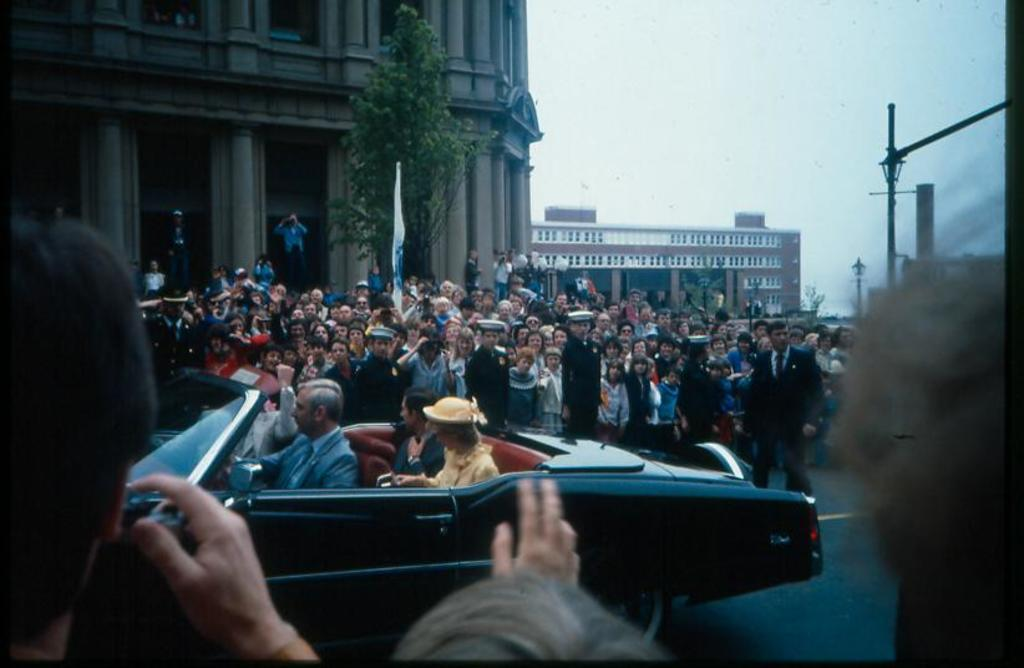How many people are inside the car in the image? There are four people sitting in the car. What can be seen in the background of the image? There is a flag, a tree, a building, and the sky visible in the background of the image. Are there any other people in the image besides the ones in the car? Yes, there is a group of people observing the car. What type of oven is being used by the lawyer during recess in the image? There is no oven, lawyer, or recess present in the image. 